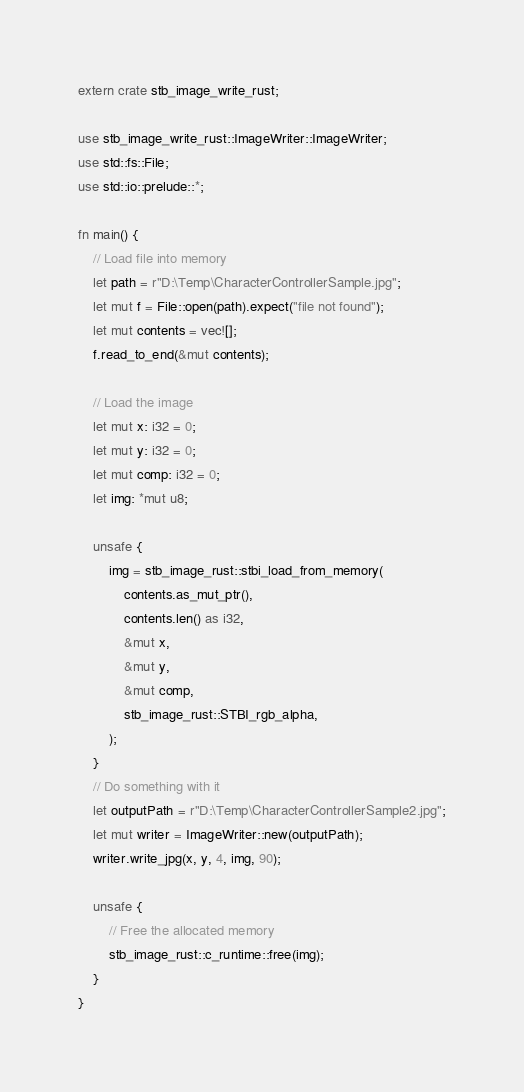<code> <loc_0><loc_0><loc_500><loc_500><_Rust_>extern crate stb_image_write_rust;

use stb_image_write_rust::ImageWriter::ImageWriter;
use std::fs::File;
use std::io::prelude::*;

fn main() {
    // Load file into memory
    let path = r"D:\Temp\CharacterControllerSample.jpg";
    let mut f = File::open(path).expect("file not found");
    let mut contents = vec![];
    f.read_to_end(&mut contents);

    // Load the image
    let mut x: i32 = 0;
    let mut y: i32 = 0;
    let mut comp: i32 = 0;
    let img: *mut u8;

    unsafe {
        img = stb_image_rust::stbi_load_from_memory(
            contents.as_mut_ptr(),
            contents.len() as i32,
            &mut x,
            &mut y,
            &mut comp,
            stb_image_rust::STBI_rgb_alpha,
        );
    }
    // Do something with it
    let outputPath = r"D:\Temp\CharacterControllerSample2.jpg";
    let mut writer = ImageWriter::new(outputPath);
    writer.write_jpg(x, y, 4, img, 90);

    unsafe {
        // Free the allocated memory
        stb_image_rust::c_runtime::free(img);
    }
}
</code> 